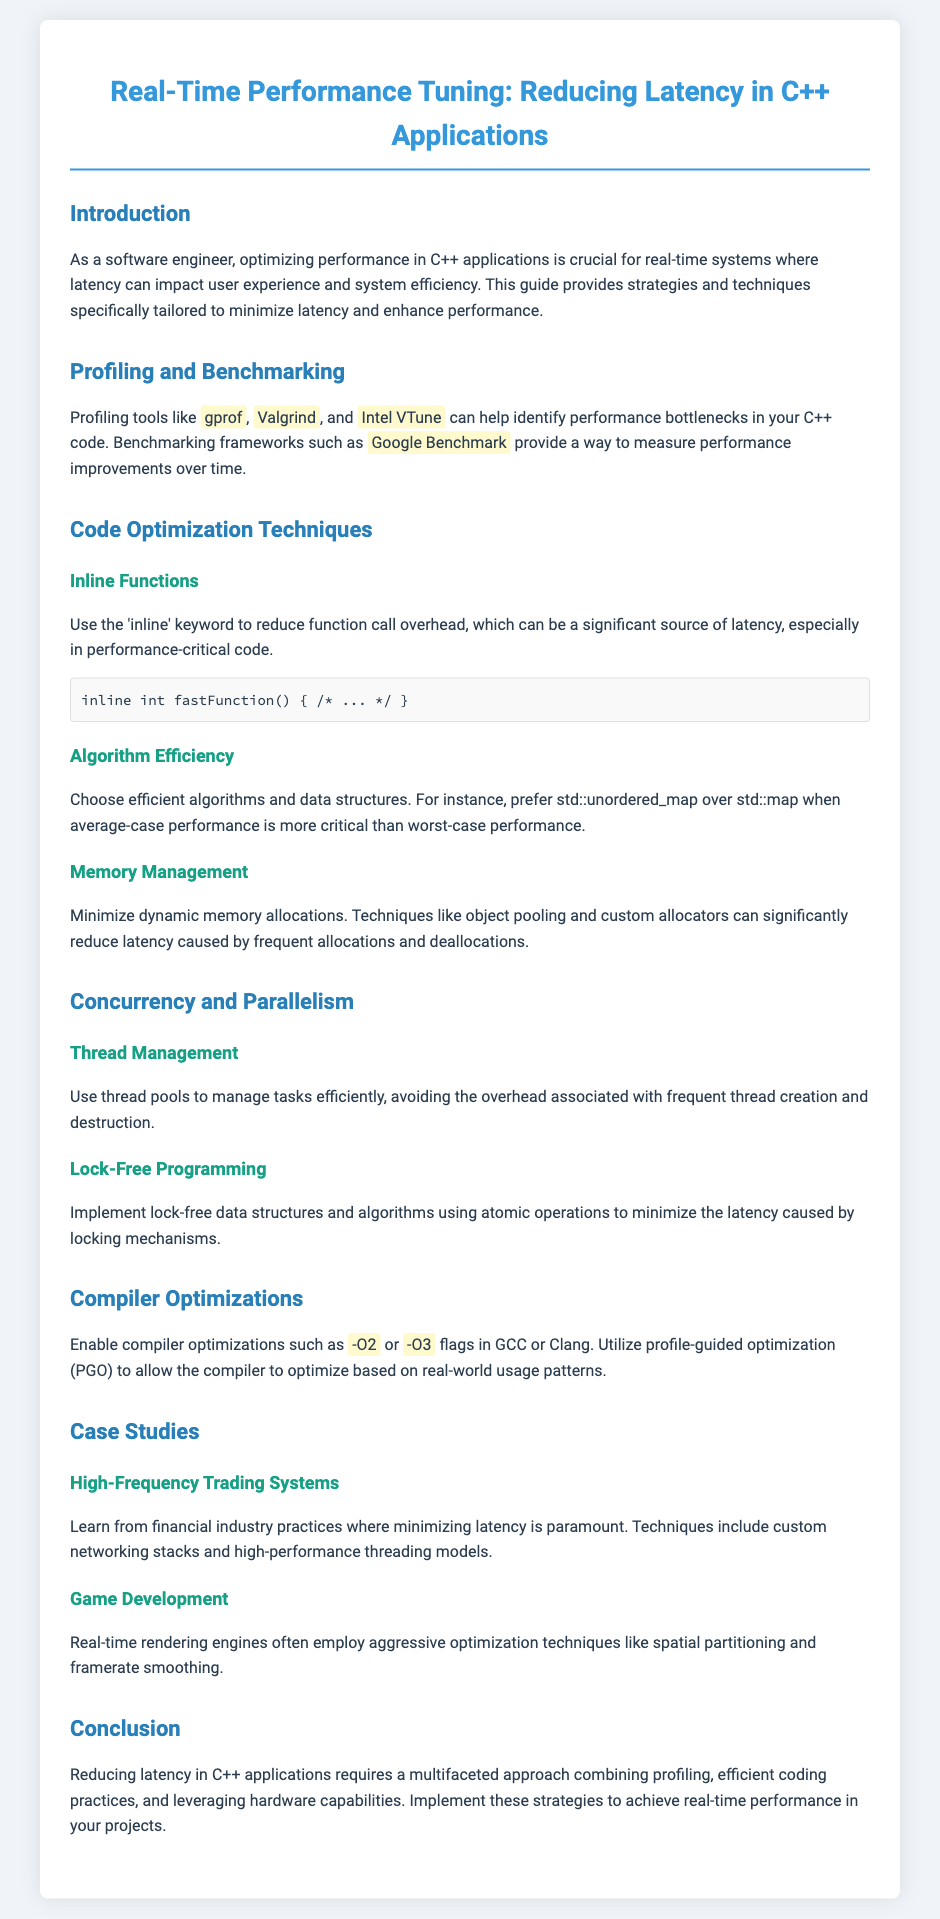What is the title of the document? The title is mentioned prominently at the top of the document, indicating the topic being addressed.
Answer: Real-Time Performance Tuning: Reducing Latency in C++ Applications Which profiling tool is mentioned for identifying performance bottlenecks? The document lists several tools under profiling and benchmarking, indicating their purpose in performance tuning.
Answer: gprof What memory management technique can significantly reduce latency? The document discusses specific techniques under code optimization that help in managing memory allocation efficiently.
Answer: Object pooling What compiler optimization flag is suggested to enable in GCC or Clang? The document provides specific examples of compiler flags that can be used to optimize performance in C++.
Answer: -O2 Name one application mentioned in the case studies. The document includes examples from different fields that illustrate the application of performance tuning techniques.
Answer: Game Development What is a suggested approach to manage tasks efficiently in concurrency? Strategies for managing concurrent tasks are discussed, highlighting methods to improve performance in multi-threaded environments.
Answer: Thread pools What should be preferred over std::map for performance-critical cases? The document emphasizes the importance of choosing appropriate data structures based on performance metrics.
Answer: std::unordered_map What is the main focus of the document? The overall goal of the content is summarized in the introduction, emphasizing performance improvements.
Answer: Reducing Latency 